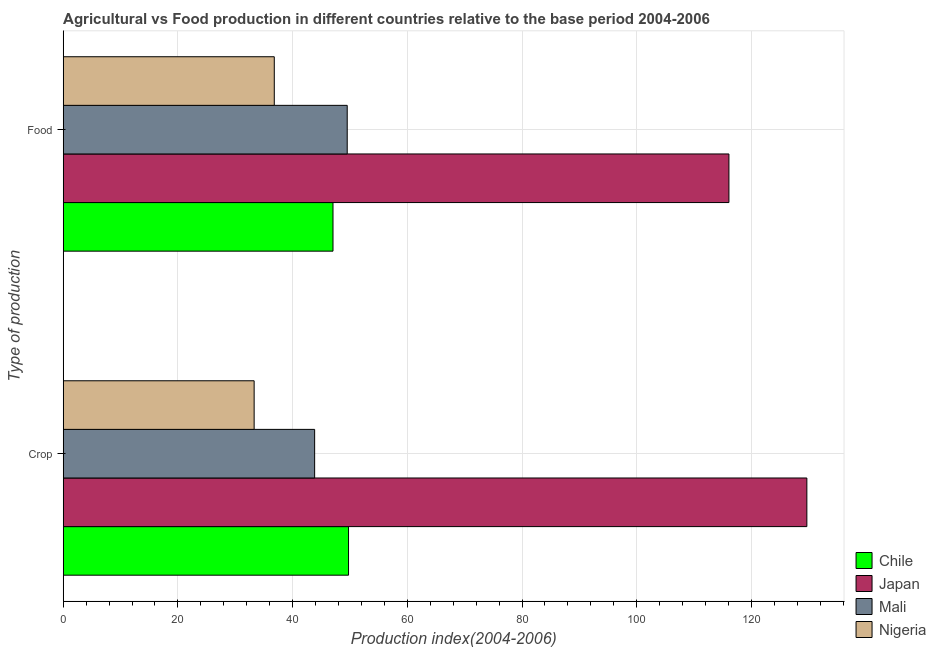How many bars are there on the 2nd tick from the top?
Provide a succinct answer. 4. What is the label of the 1st group of bars from the top?
Give a very brief answer. Food. What is the food production index in Chile?
Give a very brief answer. 47.04. Across all countries, what is the maximum crop production index?
Offer a terse response. 129.67. Across all countries, what is the minimum crop production index?
Provide a succinct answer. 33.29. In which country was the food production index maximum?
Your answer should be compact. Japan. In which country was the food production index minimum?
Ensure brevity in your answer.  Nigeria. What is the total food production index in the graph?
Make the answer very short. 249.44. What is the difference between the food production index in Nigeria and that in Japan?
Ensure brevity in your answer.  -79.28. What is the difference between the crop production index in Chile and the food production index in Nigeria?
Keep it short and to the point. 12.95. What is the average crop production index per country?
Offer a very short reply. 64.14. What is the difference between the food production index and crop production index in Nigeria?
Provide a succinct answer. 3.51. In how many countries, is the crop production index greater than 4 ?
Give a very brief answer. 4. What is the ratio of the crop production index in Mali to that in Nigeria?
Offer a very short reply. 1.32. In how many countries, is the crop production index greater than the average crop production index taken over all countries?
Your answer should be very brief. 1. What does the 3rd bar from the bottom in Crop represents?
Make the answer very short. Mali. How many countries are there in the graph?
Offer a very short reply. 4. What is the difference between two consecutive major ticks on the X-axis?
Give a very brief answer. 20. Are the values on the major ticks of X-axis written in scientific E-notation?
Ensure brevity in your answer.  No. Does the graph contain grids?
Provide a succinct answer. Yes. Where does the legend appear in the graph?
Keep it short and to the point. Bottom right. How are the legend labels stacked?
Offer a very short reply. Vertical. What is the title of the graph?
Offer a terse response. Agricultural vs Food production in different countries relative to the base period 2004-2006. What is the label or title of the X-axis?
Give a very brief answer. Production index(2004-2006). What is the label or title of the Y-axis?
Make the answer very short. Type of production. What is the Production index(2004-2006) in Chile in Crop?
Provide a short and direct response. 49.75. What is the Production index(2004-2006) in Japan in Crop?
Your answer should be very brief. 129.67. What is the Production index(2004-2006) in Mali in Crop?
Make the answer very short. 43.84. What is the Production index(2004-2006) of Nigeria in Crop?
Your answer should be compact. 33.29. What is the Production index(2004-2006) of Chile in Food?
Provide a short and direct response. 47.04. What is the Production index(2004-2006) in Japan in Food?
Keep it short and to the point. 116.08. What is the Production index(2004-2006) in Mali in Food?
Your response must be concise. 49.52. What is the Production index(2004-2006) of Nigeria in Food?
Your answer should be very brief. 36.8. Across all Type of production, what is the maximum Production index(2004-2006) of Chile?
Offer a very short reply. 49.75. Across all Type of production, what is the maximum Production index(2004-2006) of Japan?
Provide a short and direct response. 129.67. Across all Type of production, what is the maximum Production index(2004-2006) of Mali?
Offer a terse response. 49.52. Across all Type of production, what is the maximum Production index(2004-2006) in Nigeria?
Keep it short and to the point. 36.8. Across all Type of production, what is the minimum Production index(2004-2006) of Chile?
Your response must be concise. 47.04. Across all Type of production, what is the minimum Production index(2004-2006) in Japan?
Provide a succinct answer. 116.08. Across all Type of production, what is the minimum Production index(2004-2006) in Mali?
Your answer should be compact. 43.84. Across all Type of production, what is the minimum Production index(2004-2006) of Nigeria?
Ensure brevity in your answer.  33.29. What is the total Production index(2004-2006) in Chile in the graph?
Provide a succinct answer. 96.79. What is the total Production index(2004-2006) of Japan in the graph?
Provide a succinct answer. 245.75. What is the total Production index(2004-2006) of Mali in the graph?
Make the answer very short. 93.36. What is the total Production index(2004-2006) in Nigeria in the graph?
Make the answer very short. 70.09. What is the difference between the Production index(2004-2006) of Chile in Crop and that in Food?
Provide a succinct answer. 2.71. What is the difference between the Production index(2004-2006) of Japan in Crop and that in Food?
Ensure brevity in your answer.  13.59. What is the difference between the Production index(2004-2006) of Mali in Crop and that in Food?
Make the answer very short. -5.68. What is the difference between the Production index(2004-2006) in Nigeria in Crop and that in Food?
Provide a succinct answer. -3.51. What is the difference between the Production index(2004-2006) in Chile in Crop and the Production index(2004-2006) in Japan in Food?
Keep it short and to the point. -66.33. What is the difference between the Production index(2004-2006) in Chile in Crop and the Production index(2004-2006) in Mali in Food?
Give a very brief answer. 0.23. What is the difference between the Production index(2004-2006) in Chile in Crop and the Production index(2004-2006) in Nigeria in Food?
Provide a succinct answer. 12.95. What is the difference between the Production index(2004-2006) of Japan in Crop and the Production index(2004-2006) of Mali in Food?
Make the answer very short. 80.15. What is the difference between the Production index(2004-2006) of Japan in Crop and the Production index(2004-2006) of Nigeria in Food?
Keep it short and to the point. 92.87. What is the difference between the Production index(2004-2006) of Mali in Crop and the Production index(2004-2006) of Nigeria in Food?
Your answer should be very brief. 7.04. What is the average Production index(2004-2006) of Chile per Type of production?
Your response must be concise. 48.4. What is the average Production index(2004-2006) of Japan per Type of production?
Keep it short and to the point. 122.88. What is the average Production index(2004-2006) of Mali per Type of production?
Offer a very short reply. 46.68. What is the average Production index(2004-2006) of Nigeria per Type of production?
Your answer should be compact. 35.05. What is the difference between the Production index(2004-2006) in Chile and Production index(2004-2006) in Japan in Crop?
Make the answer very short. -79.92. What is the difference between the Production index(2004-2006) of Chile and Production index(2004-2006) of Mali in Crop?
Your answer should be compact. 5.91. What is the difference between the Production index(2004-2006) of Chile and Production index(2004-2006) of Nigeria in Crop?
Keep it short and to the point. 16.46. What is the difference between the Production index(2004-2006) in Japan and Production index(2004-2006) in Mali in Crop?
Offer a very short reply. 85.83. What is the difference between the Production index(2004-2006) of Japan and Production index(2004-2006) of Nigeria in Crop?
Make the answer very short. 96.38. What is the difference between the Production index(2004-2006) in Mali and Production index(2004-2006) in Nigeria in Crop?
Keep it short and to the point. 10.55. What is the difference between the Production index(2004-2006) of Chile and Production index(2004-2006) of Japan in Food?
Keep it short and to the point. -69.04. What is the difference between the Production index(2004-2006) of Chile and Production index(2004-2006) of Mali in Food?
Provide a succinct answer. -2.48. What is the difference between the Production index(2004-2006) of Chile and Production index(2004-2006) of Nigeria in Food?
Provide a succinct answer. 10.24. What is the difference between the Production index(2004-2006) of Japan and Production index(2004-2006) of Mali in Food?
Make the answer very short. 66.56. What is the difference between the Production index(2004-2006) in Japan and Production index(2004-2006) in Nigeria in Food?
Your response must be concise. 79.28. What is the difference between the Production index(2004-2006) of Mali and Production index(2004-2006) of Nigeria in Food?
Keep it short and to the point. 12.72. What is the ratio of the Production index(2004-2006) in Chile in Crop to that in Food?
Make the answer very short. 1.06. What is the ratio of the Production index(2004-2006) of Japan in Crop to that in Food?
Your answer should be very brief. 1.12. What is the ratio of the Production index(2004-2006) in Mali in Crop to that in Food?
Keep it short and to the point. 0.89. What is the ratio of the Production index(2004-2006) of Nigeria in Crop to that in Food?
Ensure brevity in your answer.  0.9. What is the difference between the highest and the second highest Production index(2004-2006) in Chile?
Give a very brief answer. 2.71. What is the difference between the highest and the second highest Production index(2004-2006) of Japan?
Make the answer very short. 13.59. What is the difference between the highest and the second highest Production index(2004-2006) of Mali?
Provide a short and direct response. 5.68. What is the difference between the highest and the second highest Production index(2004-2006) in Nigeria?
Your response must be concise. 3.51. What is the difference between the highest and the lowest Production index(2004-2006) in Chile?
Provide a succinct answer. 2.71. What is the difference between the highest and the lowest Production index(2004-2006) in Japan?
Give a very brief answer. 13.59. What is the difference between the highest and the lowest Production index(2004-2006) of Mali?
Give a very brief answer. 5.68. What is the difference between the highest and the lowest Production index(2004-2006) of Nigeria?
Provide a short and direct response. 3.51. 